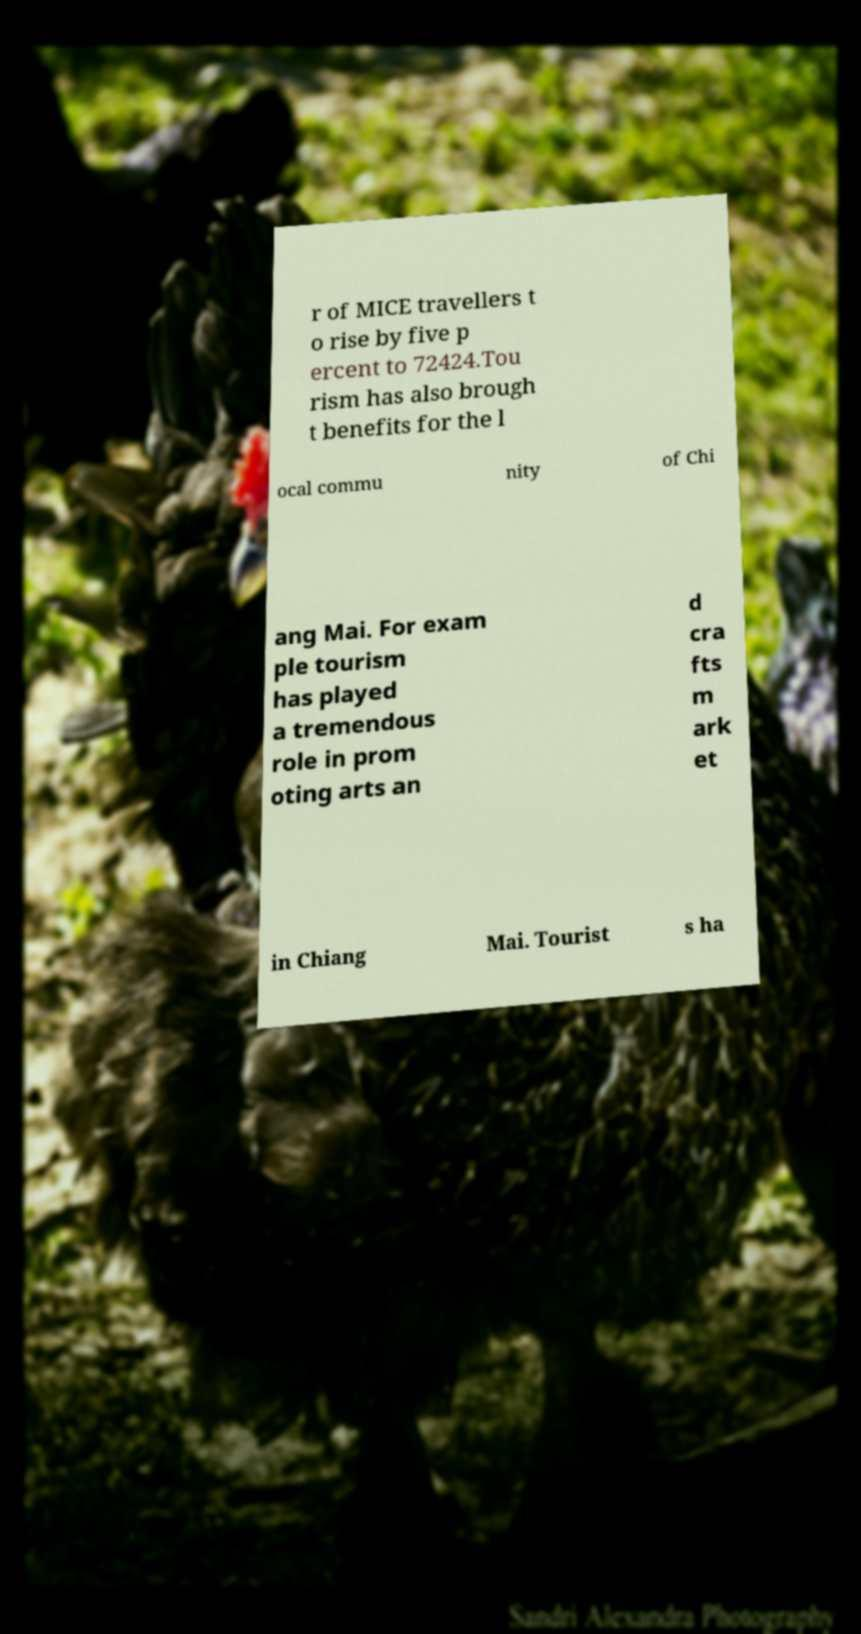Please read and relay the text visible in this image. What does it say? r of MICE travellers t o rise by five p ercent to 72424.Tou rism has also brough t benefits for the l ocal commu nity of Chi ang Mai. For exam ple tourism has played a tremendous role in prom oting arts an d cra fts m ark et in Chiang Mai. Tourist s ha 